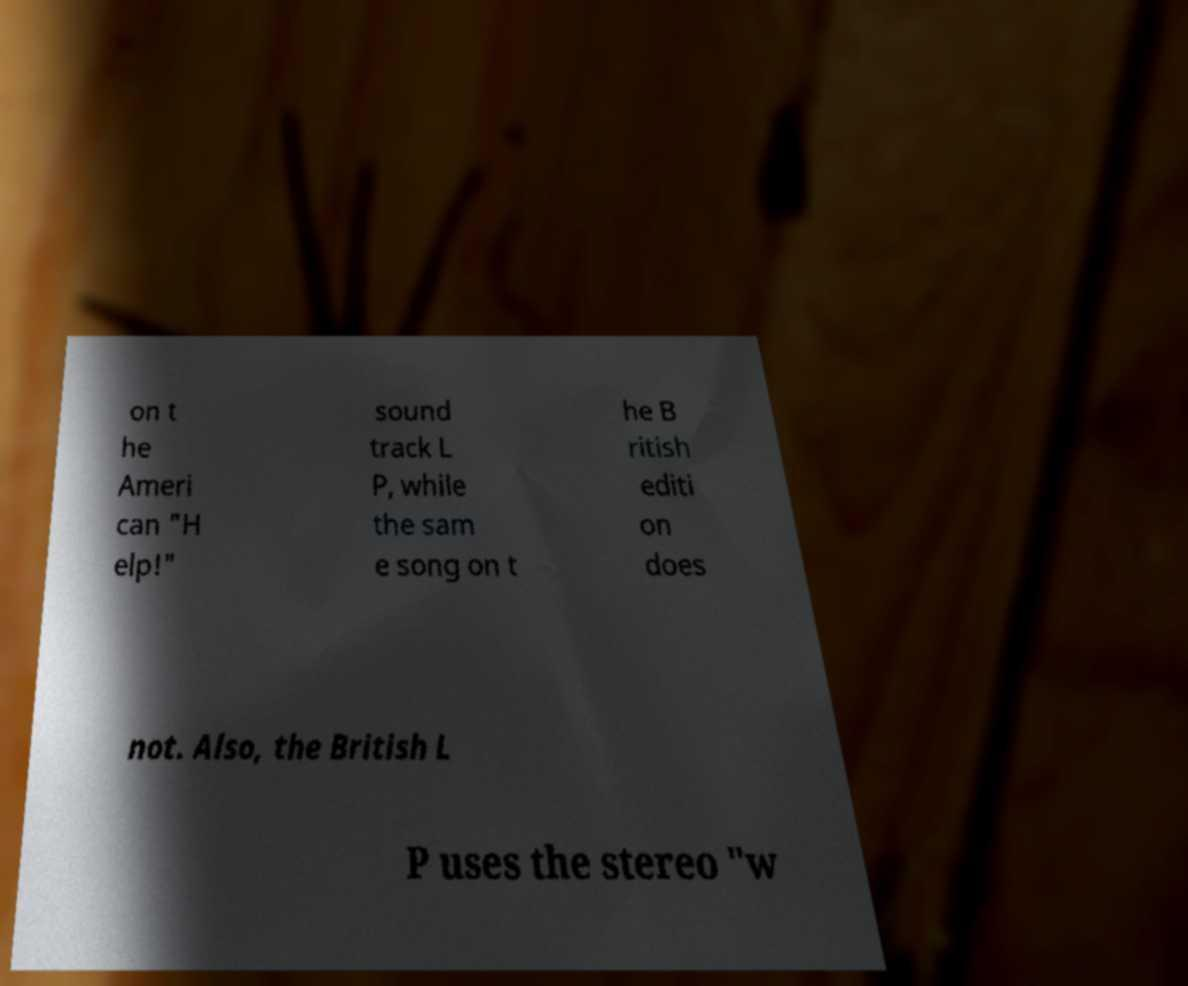Can you read and provide the text displayed in the image?This photo seems to have some interesting text. Can you extract and type it out for me? on t he Ameri can "H elp!" sound track L P, while the sam e song on t he B ritish editi on does not. Also, the British L P uses the stereo "w 